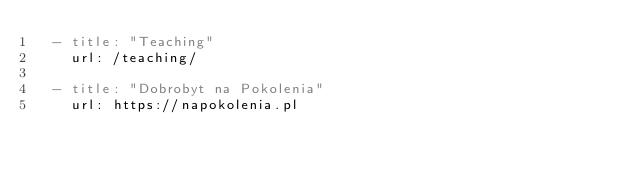Convert code to text. <code><loc_0><loc_0><loc_500><loc_500><_YAML_>  - title: "Teaching"
    url: /teaching/    
         
  - title: "Dobrobyt na Pokolenia"
    url: https://napokolenia.pl
   
</code> 